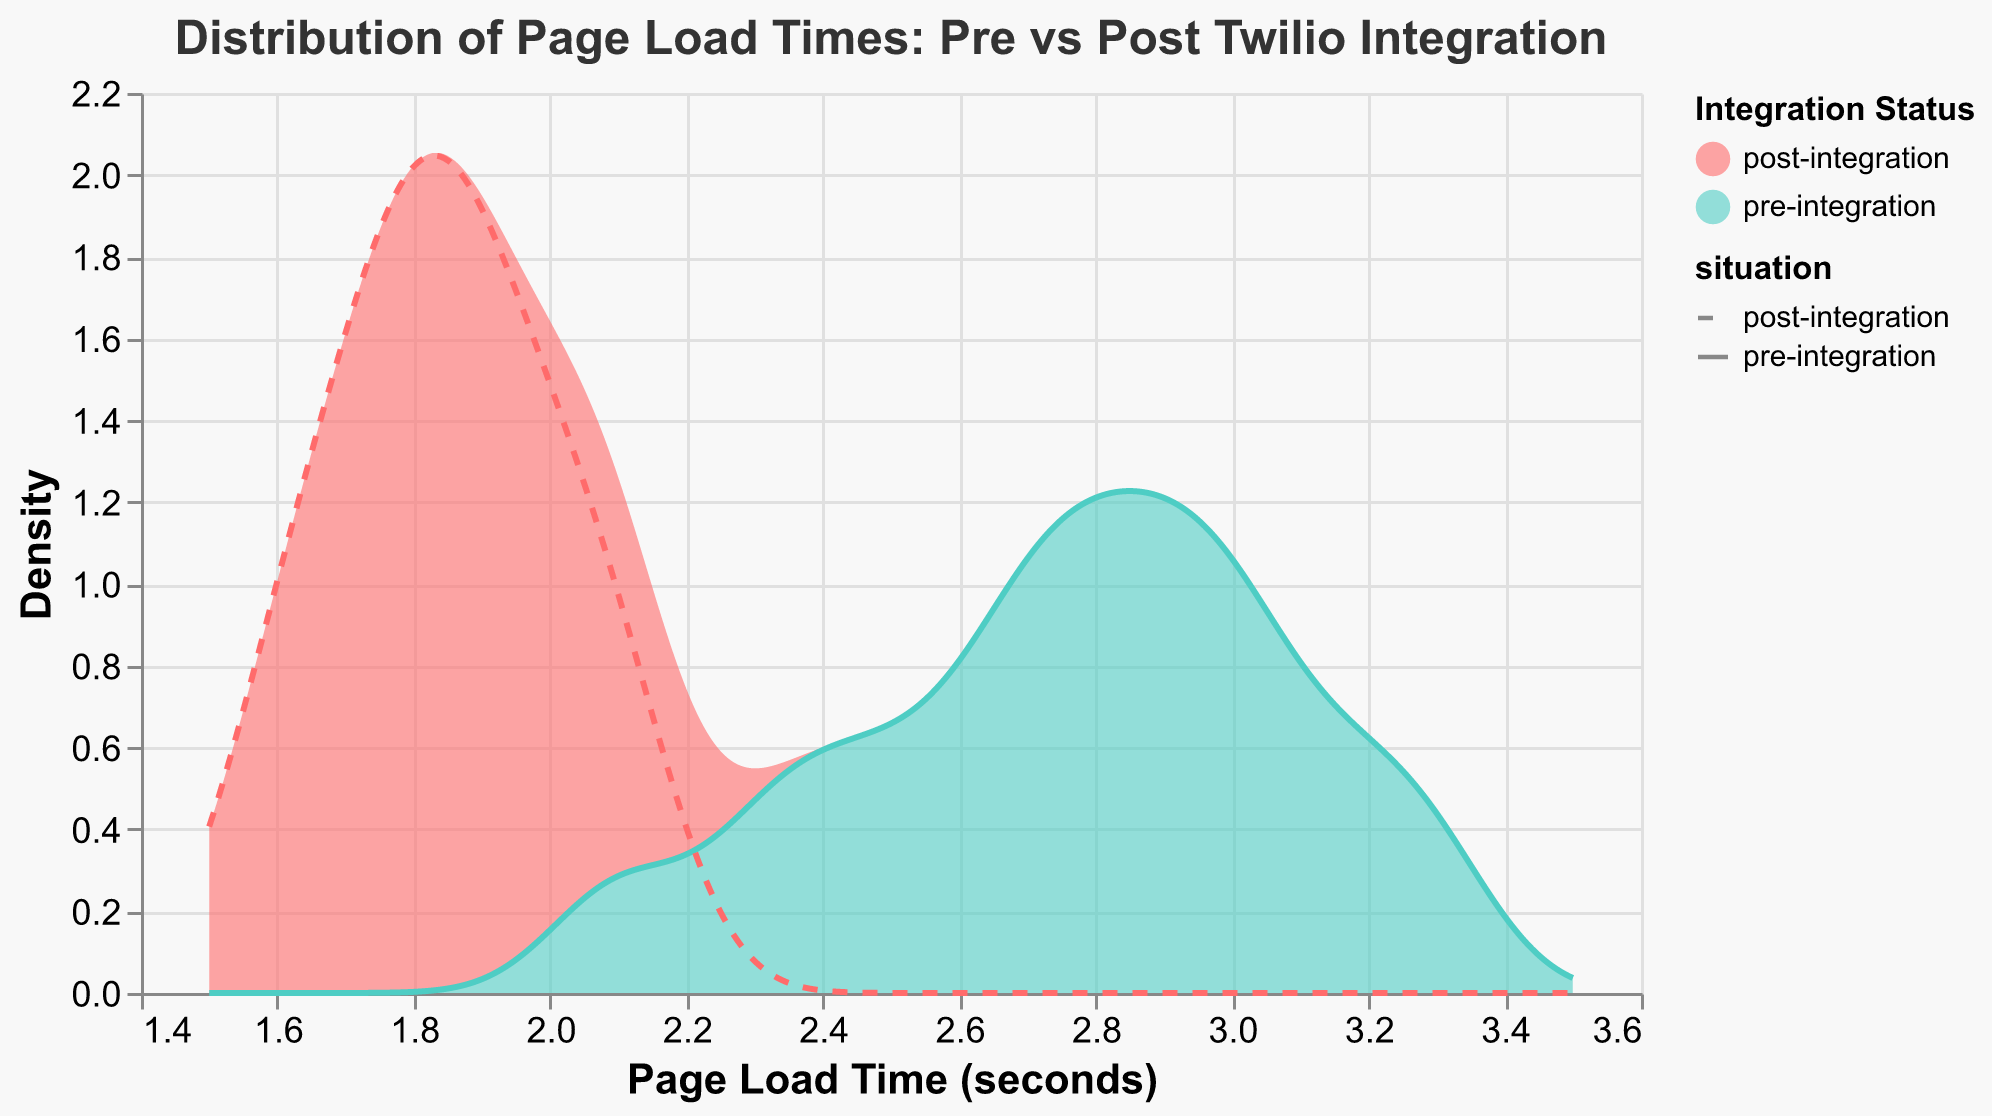What is the x-axis representing? The x-axis represents the page load time in seconds. This axis shows the range of times it takes for pages to load in the web application pre- and post-Twilio service integration.
Answer: Page load time (seconds) Which color represents the post-integration density? The legend in the plot indicates that the color representing post-integration density is a shade of teal. This is used to differentiate from the pre-integration density, which is colored red.
Answer: Teal Does the page load time decrease or increase after integrating Twilio services? By comparing the positions of the density peaks, the post-integration density peak is around 1.8 to 2.1 seconds, while the pre-integration density peak is around 2.8 to 3.0 seconds. Thus, page load times have decreased after integrating Twilio services.
Answer: Decrease What is the peak density value for the pre-integration distribution? The peak density value for the pre-integration distribution can be determined by observing the highest point in the red density plot. This peak density point appears around the 2.8-second mark.
Answer: Around 2.8 seconds Which situation has a wider spread in page load times? To determine which situation has a wider spread in page load times, visually examine the width of the density areas. The density plot for pre-integration (red) spreads from around 2.0 to 3.3 seconds, while the post-integration (teal) spreads from around 1.6 to 2.1 seconds. Therefore, pre-integration has a wider spread.
Answer: Pre-integration What is the kernel bandwidth used for the density estimation? The kernel bandwidth used for the density estimation can be inferred from the plot's configuration. Here, the bandwidth for the density estimation is set to 0.1, indicating the smoothness of the density curves.
Answer: 0.1 What is the range of page load times covered by the density plots? The extent of the density plots, as represented on the x-axis, ranges from around 1.5 to 3.5 seconds, showing the overall spread of page load times for both pre- and post-integration situations.
Answer: 1.5 to 3.5 seconds Which situation has a higher density at page load times around 2.0 seconds? Looking at the density plots around the 2.0-second mark, the teal post-integration density line is higher than the red pre-integration density line, indicating a higher density for post-integration at this page load time.
Answer: Post-integration How do the peak values of the density differ between pre- and post-integration? By examining the peaks of the density plots, the pre-integration peak (red) is around the 2.8-second mark, whereas the post-integration peak (teal) is around the 1.8 to 2.1-second mark, showing a shift to lower page load times post-integration.
Answer: Peaks are at different page load times (2.8s pre, 1.8-2.1s post) What is the main insight the plot provides about page load times pre- and post-integration? The plot demonstrates that integrating Twilio services significantly reduces page load times. This is indicated by the post-integration density peak being lower (1.8-2.1 seconds) compared to the pre-integration density peak (2.8-3.0 seconds), illustrating improved performance.
Answer: Page load times decreased post-integration 